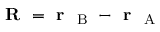<formula> <loc_0><loc_0><loc_500><loc_500>R = r _ { B } - r _ { A }</formula> 